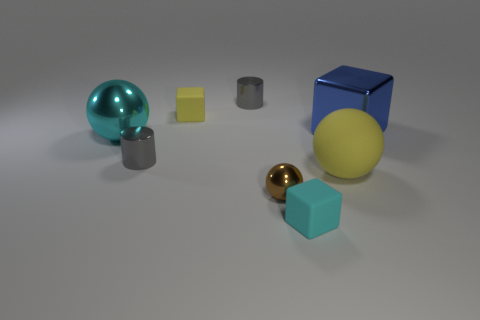Add 1 large metallic spheres. How many objects exist? 9 Subtract all tiny shiny balls. How many balls are left? 2 Subtract all blocks. How many objects are left? 5 Subtract 2 cylinders. How many cylinders are left? 0 Add 2 blue things. How many blue things are left? 3 Add 7 small yellow things. How many small yellow things exist? 8 Subtract all blue cubes. How many cubes are left? 2 Subtract 1 cyan spheres. How many objects are left? 7 Subtract all brown cylinders. Subtract all brown spheres. How many cylinders are left? 2 Subtract all yellow spheres. How many green cylinders are left? 0 